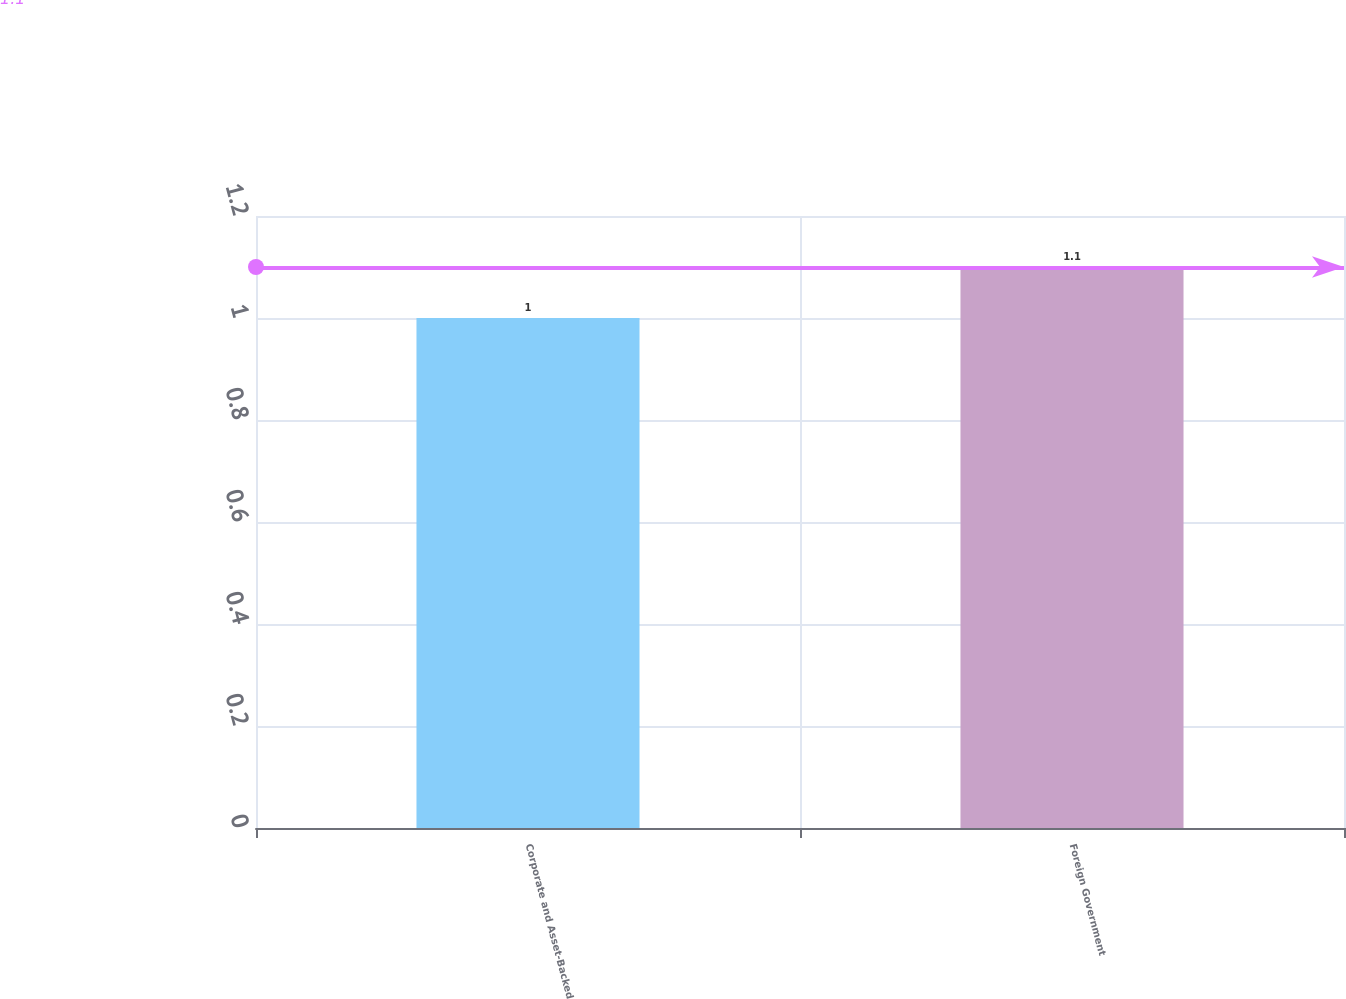Convert chart. <chart><loc_0><loc_0><loc_500><loc_500><bar_chart><fcel>Corporate and Asset-Backed<fcel>Foreign Government<nl><fcel>1<fcel>1.1<nl></chart> 